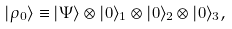<formula> <loc_0><loc_0><loc_500><loc_500>| \rho _ { 0 } \rangle \equiv | \Psi \rangle \otimes | 0 \rangle _ { 1 } \otimes | 0 \rangle _ { 2 } \otimes | 0 \rangle _ { 3 } ,</formula> 